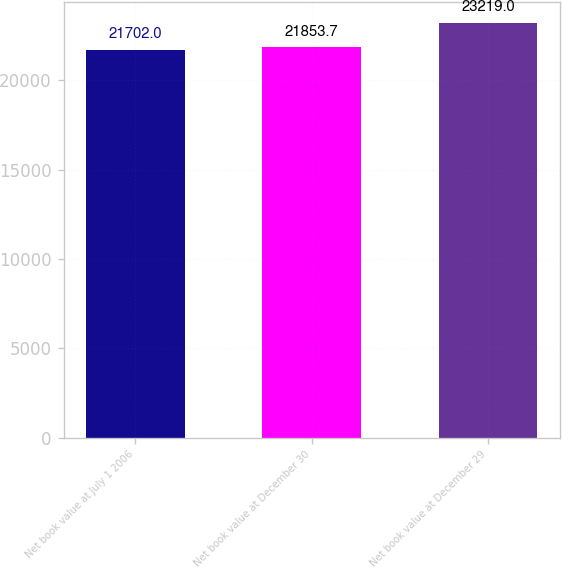<chart> <loc_0><loc_0><loc_500><loc_500><bar_chart><fcel>Net book value at July 1 2006<fcel>Net book value at December 30<fcel>Net book value at December 29<nl><fcel>21702<fcel>21853.7<fcel>23219<nl></chart> 